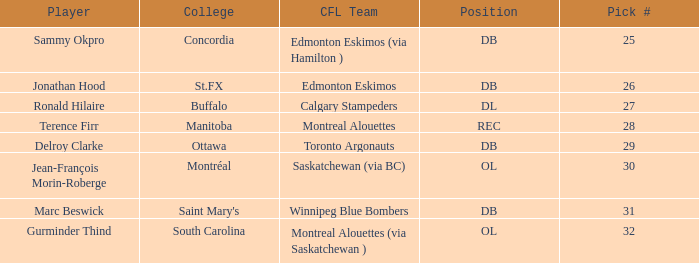Which Pick # has a College of concordia? 25.0. 